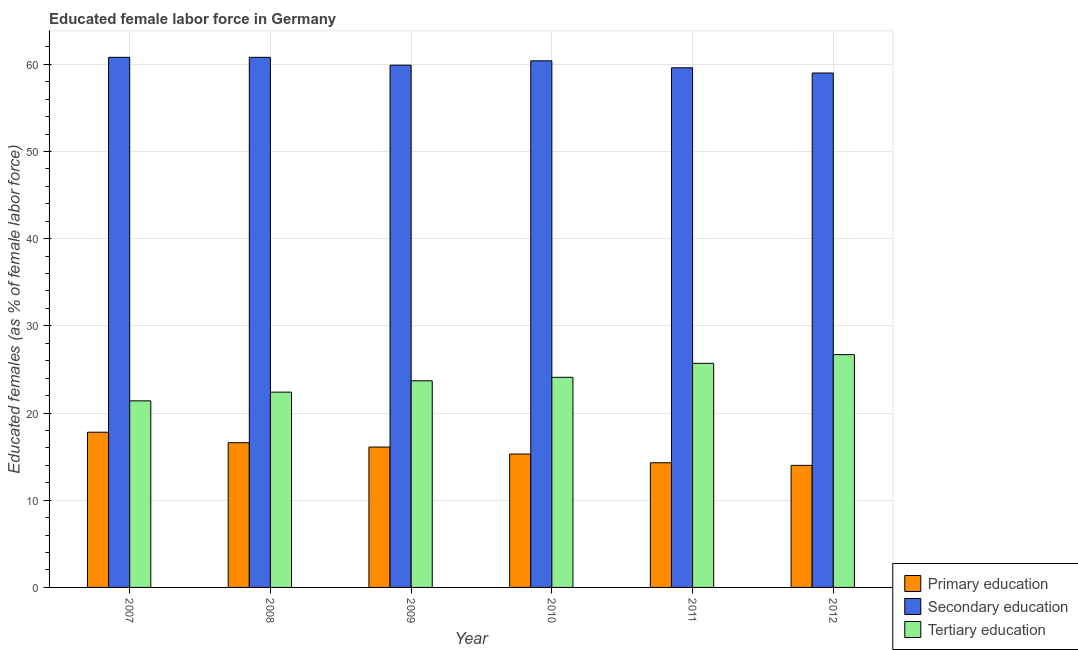How many different coloured bars are there?
Provide a short and direct response. 3. How many groups of bars are there?
Your answer should be very brief. 6. Are the number of bars per tick equal to the number of legend labels?
Ensure brevity in your answer.  Yes. Are the number of bars on each tick of the X-axis equal?
Provide a succinct answer. Yes. How many bars are there on the 4th tick from the right?
Offer a very short reply. 3. What is the percentage of female labor force who received tertiary education in 2011?
Your answer should be compact. 25.7. Across all years, what is the maximum percentage of female labor force who received secondary education?
Provide a short and direct response. 60.8. Across all years, what is the minimum percentage of female labor force who received primary education?
Keep it short and to the point. 14. In which year was the percentage of female labor force who received primary education minimum?
Offer a terse response. 2012. What is the total percentage of female labor force who received primary education in the graph?
Make the answer very short. 94.1. What is the difference between the percentage of female labor force who received secondary education in 2007 and that in 2008?
Offer a very short reply. 0. What is the average percentage of female labor force who received tertiary education per year?
Your answer should be very brief. 24. In how many years, is the percentage of female labor force who received secondary education greater than 48 %?
Provide a short and direct response. 6. What is the ratio of the percentage of female labor force who received primary education in 2008 to that in 2011?
Ensure brevity in your answer.  1.16. What is the difference between the highest and the lowest percentage of female labor force who received secondary education?
Offer a terse response. 1.8. Is the sum of the percentage of female labor force who received secondary education in 2008 and 2012 greater than the maximum percentage of female labor force who received primary education across all years?
Offer a terse response. Yes. What does the 1st bar from the left in 2009 represents?
Provide a short and direct response. Primary education. Are all the bars in the graph horizontal?
Provide a short and direct response. No. What is the difference between two consecutive major ticks on the Y-axis?
Make the answer very short. 10. Are the values on the major ticks of Y-axis written in scientific E-notation?
Offer a very short reply. No. Does the graph contain any zero values?
Ensure brevity in your answer.  No. Does the graph contain grids?
Your response must be concise. Yes. Where does the legend appear in the graph?
Make the answer very short. Bottom right. How many legend labels are there?
Offer a terse response. 3. What is the title of the graph?
Make the answer very short. Educated female labor force in Germany. Does "Errors" appear as one of the legend labels in the graph?
Offer a terse response. No. What is the label or title of the X-axis?
Provide a short and direct response. Year. What is the label or title of the Y-axis?
Ensure brevity in your answer.  Educated females (as % of female labor force). What is the Educated females (as % of female labor force) of Primary education in 2007?
Give a very brief answer. 17.8. What is the Educated females (as % of female labor force) of Secondary education in 2007?
Offer a very short reply. 60.8. What is the Educated females (as % of female labor force) of Tertiary education in 2007?
Your response must be concise. 21.4. What is the Educated females (as % of female labor force) in Primary education in 2008?
Ensure brevity in your answer.  16.6. What is the Educated females (as % of female labor force) in Secondary education in 2008?
Ensure brevity in your answer.  60.8. What is the Educated females (as % of female labor force) in Tertiary education in 2008?
Keep it short and to the point. 22.4. What is the Educated females (as % of female labor force) in Primary education in 2009?
Give a very brief answer. 16.1. What is the Educated females (as % of female labor force) of Secondary education in 2009?
Offer a very short reply. 59.9. What is the Educated females (as % of female labor force) of Tertiary education in 2009?
Offer a very short reply. 23.7. What is the Educated females (as % of female labor force) of Primary education in 2010?
Make the answer very short. 15.3. What is the Educated females (as % of female labor force) in Secondary education in 2010?
Provide a succinct answer. 60.4. What is the Educated females (as % of female labor force) in Tertiary education in 2010?
Keep it short and to the point. 24.1. What is the Educated females (as % of female labor force) of Primary education in 2011?
Offer a very short reply. 14.3. What is the Educated females (as % of female labor force) in Secondary education in 2011?
Offer a very short reply. 59.6. What is the Educated females (as % of female labor force) of Tertiary education in 2011?
Your response must be concise. 25.7. What is the Educated females (as % of female labor force) of Tertiary education in 2012?
Give a very brief answer. 26.7. Across all years, what is the maximum Educated females (as % of female labor force) in Primary education?
Ensure brevity in your answer.  17.8. Across all years, what is the maximum Educated females (as % of female labor force) of Secondary education?
Offer a terse response. 60.8. Across all years, what is the maximum Educated females (as % of female labor force) in Tertiary education?
Ensure brevity in your answer.  26.7. Across all years, what is the minimum Educated females (as % of female labor force) in Primary education?
Offer a very short reply. 14. Across all years, what is the minimum Educated females (as % of female labor force) of Secondary education?
Make the answer very short. 59. Across all years, what is the minimum Educated females (as % of female labor force) in Tertiary education?
Provide a short and direct response. 21.4. What is the total Educated females (as % of female labor force) in Primary education in the graph?
Your response must be concise. 94.1. What is the total Educated females (as % of female labor force) in Secondary education in the graph?
Your response must be concise. 360.5. What is the total Educated females (as % of female labor force) of Tertiary education in the graph?
Offer a terse response. 144. What is the difference between the Educated females (as % of female labor force) in Tertiary education in 2007 and that in 2008?
Ensure brevity in your answer.  -1. What is the difference between the Educated females (as % of female labor force) of Secondary education in 2007 and that in 2009?
Your response must be concise. 0.9. What is the difference between the Educated females (as % of female labor force) in Primary education in 2007 and that in 2010?
Offer a terse response. 2.5. What is the difference between the Educated females (as % of female labor force) in Primary education in 2007 and that in 2012?
Offer a very short reply. 3.8. What is the difference between the Educated females (as % of female labor force) in Secondary education in 2007 and that in 2012?
Ensure brevity in your answer.  1.8. What is the difference between the Educated females (as % of female labor force) of Primary education in 2008 and that in 2010?
Offer a very short reply. 1.3. What is the difference between the Educated females (as % of female labor force) in Secondary education in 2008 and that in 2011?
Your answer should be very brief. 1.2. What is the difference between the Educated females (as % of female labor force) in Primary education in 2008 and that in 2012?
Make the answer very short. 2.6. What is the difference between the Educated females (as % of female labor force) of Secondary education in 2008 and that in 2012?
Offer a very short reply. 1.8. What is the difference between the Educated females (as % of female labor force) in Primary education in 2009 and that in 2010?
Provide a short and direct response. 0.8. What is the difference between the Educated females (as % of female labor force) in Secondary education in 2009 and that in 2010?
Your response must be concise. -0.5. What is the difference between the Educated females (as % of female labor force) of Primary education in 2009 and that in 2011?
Ensure brevity in your answer.  1.8. What is the difference between the Educated females (as % of female labor force) of Tertiary education in 2009 and that in 2011?
Provide a short and direct response. -2. What is the difference between the Educated females (as % of female labor force) of Secondary education in 2009 and that in 2012?
Provide a short and direct response. 0.9. What is the difference between the Educated females (as % of female labor force) of Tertiary education in 2009 and that in 2012?
Offer a terse response. -3. What is the difference between the Educated females (as % of female labor force) in Secondary education in 2010 and that in 2011?
Make the answer very short. 0.8. What is the difference between the Educated females (as % of female labor force) in Secondary education in 2010 and that in 2012?
Offer a very short reply. 1.4. What is the difference between the Educated females (as % of female labor force) of Primary education in 2011 and that in 2012?
Your answer should be very brief. 0.3. What is the difference between the Educated females (as % of female labor force) in Secondary education in 2011 and that in 2012?
Ensure brevity in your answer.  0.6. What is the difference between the Educated females (as % of female labor force) in Tertiary education in 2011 and that in 2012?
Give a very brief answer. -1. What is the difference between the Educated females (as % of female labor force) in Primary education in 2007 and the Educated females (as % of female labor force) in Secondary education in 2008?
Provide a short and direct response. -43. What is the difference between the Educated females (as % of female labor force) of Primary education in 2007 and the Educated females (as % of female labor force) of Tertiary education in 2008?
Keep it short and to the point. -4.6. What is the difference between the Educated females (as % of female labor force) of Secondary education in 2007 and the Educated females (as % of female labor force) of Tertiary education in 2008?
Your answer should be very brief. 38.4. What is the difference between the Educated females (as % of female labor force) in Primary education in 2007 and the Educated females (as % of female labor force) in Secondary education in 2009?
Ensure brevity in your answer.  -42.1. What is the difference between the Educated females (as % of female labor force) in Primary education in 2007 and the Educated females (as % of female labor force) in Tertiary education in 2009?
Make the answer very short. -5.9. What is the difference between the Educated females (as % of female labor force) of Secondary education in 2007 and the Educated females (as % of female labor force) of Tertiary education in 2009?
Give a very brief answer. 37.1. What is the difference between the Educated females (as % of female labor force) in Primary education in 2007 and the Educated females (as % of female labor force) in Secondary education in 2010?
Offer a very short reply. -42.6. What is the difference between the Educated females (as % of female labor force) of Secondary education in 2007 and the Educated females (as % of female labor force) of Tertiary education in 2010?
Ensure brevity in your answer.  36.7. What is the difference between the Educated females (as % of female labor force) of Primary education in 2007 and the Educated females (as % of female labor force) of Secondary education in 2011?
Make the answer very short. -41.8. What is the difference between the Educated females (as % of female labor force) in Primary education in 2007 and the Educated females (as % of female labor force) in Tertiary education in 2011?
Offer a very short reply. -7.9. What is the difference between the Educated females (as % of female labor force) of Secondary education in 2007 and the Educated females (as % of female labor force) of Tertiary education in 2011?
Ensure brevity in your answer.  35.1. What is the difference between the Educated females (as % of female labor force) in Primary education in 2007 and the Educated females (as % of female labor force) in Secondary education in 2012?
Ensure brevity in your answer.  -41.2. What is the difference between the Educated females (as % of female labor force) in Secondary education in 2007 and the Educated females (as % of female labor force) in Tertiary education in 2012?
Provide a succinct answer. 34.1. What is the difference between the Educated females (as % of female labor force) in Primary education in 2008 and the Educated females (as % of female labor force) in Secondary education in 2009?
Offer a very short reply. -43.3. What is the difference between the Educated females (as % of female labor force) in Secondary education in 2008 and the Educated females (as % of female labor force) in Tertiary education in 2009?
Your response must be concise. 37.1. What is the difference between the Educated females (as % of female labor force) of Primary education in 2008 and the Educated females (as % of female labor force) of Secondary education in 2010?
Your answer should be very brief. -43.8. What is the difference between the Educated females (as % of female labor force) in Secondary education in 2008 and the Educated females (as % of female labor force) in Tertiary education in 2010?
Offer a very short reply. 36.7. What is the difference between the Educated females (as % of female labor force) in Primary education in 2008 and the Educated females (as % of female labor force) in Secondary education in 2011?
Your answer should be compact. -43. What is the difference between the Educated females (as % of female labor force) of Primary education in 2008 and the Educated females (as % of female labor force) of Tertiary education in 2011?
Offer a terse response. -9.1. What is the difference between the Educated females (as % of female labor force) of Secondary education in 2008 and the Educated females (as % of female labor force) of Tertiary education in 2011?
Provide a short and direct response. 35.1. What is the difference between the Educated females (as % of female labor force) in Primary education in 2008 and the Educated females (as % of female labor force) in Secondary education in 2012?
Give a very brief answer. -42.4. What is the difference between the Educated females (as % of female labor force) of Primary education in 2008 and the Educated females (as % of female labor force) of Tertiary education in 2012?
Provide a short and direct response. -10.1. What is the difference between the Educated females (as % of female labor force) in Secondary education in 2008 and the Educated females (as % of female labor force) in Tertiary education in 2012?
Your answer should be very brief. 34.1. What is the difference between the Educated females (as % of female labor force) in Primary education in 2009 and the Educated females (as % of female labor force) in Secondary education in 2010?
Make the answer very short. -44.3. What is the difference between the Educated females (as % of female labor force) in Primary education in 2009 and the Educated females (as % of female labor force) in Tertiary education in 2010?
Offer a terse response. -8. What is the difference between the Educated females (as % of female labor force) of Secondary education in 2009 and the Educated females (as % of female labor force) of Tertiary education in 2010?
Provide a short and direct response. 35.8. What is the difference between the Educated females (as % of female labor force) in Primary education in 2009 and the Educated females (as % of female labor force) in Secondary education in 2011?
Your answer should be very brief. -43.5. What is the difference between the Educated females (as % of female labor force) of Primary education in 2009 and the Educated females (as % of female labor force) of Tertiary education in 2011?
Offer a terse response. -9.6. What is the difference between the Educated females (as % of female labor force) of Secondary education in 2009 and the Educated females (as % of female labor force) of Tertiary education in 2011?
Provide a succinct answer. 34.2. What is the difference between the Educated females (as % of female labor force) in Primary education in 2009 and the Educated females (as % of female labor force) in Secondary education in 2012?
Your answer should be very brief. -42.9. What is the difference between the Educated females (as % of female labor force) in Secondary education in 2009 and the Educated females (as % of female labor force) in Tertiary education in 2012?
Give a very brief answer. 33.2. What is the difference between the Educated females (as % of female labor force) in Primary education in 2010 and the Educated females (as % of female labor force) in Secondary education in 2011?
Provide a short and direct response. -44.3. What is the difference between the Educated females (as % of female labor force) of Primary education in 2010 and the Educated females (as % of female labor force) of Tertiary education in 2011?
Keep it short and to the point. -10.4. What is the difference between the Educated females (as % of female labor force) in Secondary education in 2010 and the Educated females (as % of female labor force) in Tertiary education in 2011?
Your answer should be very brief. 34.7. What is the difference between the Educated females (as % of female labor force) in Primary education in 2010 and the Educated females (as % of female labor force) in Secondary education in 2012?
Provide a succinct answer. -43.7. What is the difference between the Educated females (as % of female labor force) of Secondary education in 2010 and the Educated females (as % of female labor force) of Tertiary education in 2012?
Keep it short and to the point. 33.7. What is the difference between the Educated females (as % of female labor force) of Primary education in 2011 and the Educated females (as % of female labor force) of Secondary education in 2012?
Make the answer very short. -44.7. What is the difference between the Educated females (as % of female labor force) in Primary education in 2011 and the Educated females (as % of female labor force) in Tertiary education in 2012?
Give a very brief answer. -12.4. What is the difference between the Educated females (as % of female labor force) in Secondary education in 2011 and the Educated females (as % of female labor force) in Tertiary education in 2012?
Your response must be concise. 32.9. What is the average Educated females (as % of female labor force) in Primary education per year?
Your answer should be very brief. 15.68. What is the average Educated females (as % of female labor force) in Secondary education per year?
Your answer should be compact. 60.08. In the year 2007, what is the difference between the Educated females (as % of female labor force) in Primary education and Educated females (as % of female labor force) in Secondary education?
Make the answer very short. -43. In the year 2007, what is the difference between the Educated females (as % of female labor force) of Primary education and Educated females (as % of female labor force) of Tertiary education?
Ensure brevity in your answer.  -3.6. In the year 2007, what is the difference between the Educated females (as % of female labor force) of Secondary education and Educated females (as % of female labor force) of Tertiary education?
Your answer should be compact. 39.4. In the year 2008, what is the difference between the Educated females (as % of female labor force) of Primary education and Educated females (as % of female labor force) of Secondary education?
Give a very brief answer. -44.2. In the year 2008, what is the difference between the Educated females (as % of female labor force) of Secondary education and Educated females (as % of female labor force) of Tertiary education?
Your answer should be very brief. 38.4. In the year 2009, what is the difference between the Educated females (as % of female labor force) in Primary education and Educated females (as % of female labor force) in Secondary education?
Give a very brief answer. -43.8. In the year 2009, what is the difference between the Educated females (as % of female labor force) in Secondary education and Educated females (as % of female labor force) in Tertiary education?
Keep it short and to the point. 36.2. In the year 2010, what is the difference between the Educated females (as % of female labor force) in Primary education and Educated females (as % of female labor force) in Secondary education?
Ensure brevity in your answer.  -45.1. In the year 2010, what is the difference between the Educated females (as % of female labor force) of Primary education and Educated females (as % of female labor force) of Tertiary education?
Your response must be concise. -8.8. In the year 2010, what is the difference between the Educated females (as % of female labor force) of Secondary education and Educated females (as % of female labor force) of Tertiary education?
Ensure brevity in your answer.  36.3. In the year 2011, what is the difference between the Educated females (as % of female labor force) in Primary education and Educated females (as % of female labor force) in Secondary education?
Provide a short and direct response. -45.3. In the year 2011, what is the difference between the Educated females (as % of female labor force) in Primary education and Educated females (as % of female labor force) in Tertiary education?
Provide a short and direct response. -11.4. In the year 2011, what is the difference between the Educated females (as % of female labor force) of Secondary education and Educated females (as % of female labor force) of Tertiary education?
Keep it short and to the point. 33.9. In the year 2012, what is the difference between the Educated females (as % of female labor force) of Primary education and Educated females (as % of female labor force) of Secondary education?
Your answer should be very brief. -45. In the year 2012, what is the difference between the Educated females (as % of female labor force) of Primary education and Educated females (as % of female labor force) of Tertiary education?
Your answer should be compact. -12.7. In the year 2012, what is the difference between the Educated females (as % of female labor force) of Secondary education and Educated females (as % of female labor force) of Tertiary education?
Offer a very short reply. 32.3. What is the ratio of the Educated females (as % of female labor force) of Primary education in 2007 to that in 2008?
Your answer should be very brief. 1.07. What is the ratio of the Educated females (as % of female labor force) of Tertiary education in 2007 to that in 2008?
Provide a succinct answer. 0.96. What is the ratio of the Educated females (as % of female labor force) of Primary education in 2007 to that in 2009?
Ensure brevity in your answer.  1.11. What is the ratio of the Educated females (as % of female labor force) of Tertiary education in 2007 to that in 2009?
Make the answer very short. 0.9. What is the ratio of the Educated females (as % of female labor force) in Primary education in 2007 to that in 2010?
Offer a very short reply. 1.16. What is the ratio of the Educated females (as % of female labor force) in Secondary education in 2007 to that in 2010?
Offer a very short reply. 1.01. What is the ratio of the Educated females (as % of female labor force) of Tertiary education in 2007 to that in 2010?
Offer a terse response. 0.89. What is the ratio of the Educated females (as % of female labor force) of Primary education in 2007 to that in 2011?
Make the answer very short. 1.24. What is the ratio of the Educated females (as % of female labor force) of Secondary education in 2007 to that in 2011?
Keep it short and to the point. 1.02. What is the ratio of the Educated females (as % of female labor force) in Tertiary education in 2007 to that in 2011?
Give a very brief answer. 0.83. What is the ratio of the Educated females (as % of female labor force) in Primary education in 2007 to that in 2012?
Keep it short and to the point. 1.27. What is the ratio of the Educated females (as % of female labor force) in Secondary education in 2007 to that in 2012?
Keep it short and to the point. 1.03. What is the ratio of the Educated females (as % of female labor force) in Tertiary education in 2007 to that in 2012?
Provide a succinct answer. 0.8. What is the ratio of the Educated females (as % of female labor force) in Primary education in 2008 to that in 2009?
Provide a short and direct response. 1.03. What is the ratio of the Educated females (as % of female labor force) in Tertiary education in 2008 to that in 2009?
Offer a terse response. 0.95. What is the ratio of the Educated females (as % of female labor force) in Primary education in 2008 to that in 2010?
Offer a very short reply. 1.08. What is the ratio of the Educated females (as % of female labor force) of Secondary education in 2008 to that in 2010?
Your answer should be compact. 1.01. What is the ratio of the Educated females (as % of female labor force) of Tertiary education in 2008 to that in 2010?
Your response must be concise. 0.93. What is the ratio of the Educated females (as % of female labor force) of Primary education in 2008 to that in 2011?
Give a very brief answer. 1.16. What is the ratio of the Educated females (as % of female labor force) in Secondary education in 2008 to that in 2011?
Your response must be concise. 1.02. What is the ratio of the Educated females (as % of female labor force) in Tertiary education in 2008 to that in 2011?
Keep it short and to the point. 0.87. What is the ratio of the Educated females (as % of female labor force) in Primary education in 2008 to that in 2012?
Your answer should be compact. 1.19. What is the ratio of the Educated females (as % of female labor force) in Secondary education in 2008 to that in 2012?
Ensure brevity in your answer.  1.03. What is the ratio of the Educated females (as % of female labor force) of Tertiary education in 2008 to that in 2012?
Your answer should be compact. 0.84. What is the ratio of the Educated females (as % of female labor force) of Primary education in 2009 to that in 2010?
Offer a terse response. 1.05. What is the ratio of the Educated females (as % of female labor force) of Tertiary education in 2009 to that in 2010?
Ensure brevity in your answer.  0.98. What is the ratio of the Educated females (as % of female labor force) in Primary education in 2009 to that in 2011?
Offer a terse response. 1.13. What is the ratio of the Educated females (as % of female labor force) of Tertiary education in 2009 to that in 2011?
Ensure brevity in your answer.  0.92. What is the ratio of the Educated females (as % of female labor force) of Primary education in 2009 to that in 2012?
Give a very brief answer. 1.15. What is the ratio of the Educated females (as % of female labor force) of Secondary education in 2009 to that in 2012?
Your answer should be very brief. 1.02. What is the ratio of the Educated females (as % of female labor force) in Tertiary education in 2009 to that in 2012?
Make the answer very short. 0.89. What is the ratio of the Educated females (as % of female labor force) of Primary education in 2010 to that in 2011?
Offer a terse response. 1.07. What is the ratio of the Educated females (as % of female labor force) in Secondary education in 2010 to that in 2011?
Your answer should be very brief. 1.01. What is the ratio of the Educated females (as % of female labor force) in Tertiary education in 2010 to that in 2011?
Provide a short and direct response. 0.94. What is the ratio of the Educated females (as % of female labor force) of Primary education in 2010 to that in 2012?
Keep it short and to the point. 1.09. What is the ratio of the Educated females (as % of female labor force) of Secondary education in 2010 to that in 2012?
Offer a very short reply. 1.02. What is the ratio of the Educated females (as % of female labor force) of Tertiary education in 2010 to that in 2012?
Offer a terse response. 0.9. What is the ratio of the Educated females (as % of female labor force) in Primary education in 2011 to that in 2012?
Keep it short and to the point. 1.02. What is the ratio of the Educated females (as % of female labor force) in Secondary education in 2011 to that in 2012?
Give a very brief answer. 1.01. What is the ratio of the Educated females (as % of female labor force) of Tertiary education in 2011 to that in 2012?
Offer a terse response. 0.96. What is the difference between the highest and the second highest Educated females (as % of female labor force) of Primary education?
Provide a short and direct response. 1.2. What is the difference between the highest and the second highest Educated females (as % of female labor force) of Secondary education?
Ensure brevity in your answer.  0. What is the difference between the highest and the lowest Educated females (as % of female labor force) of Primary education?
Your answer should be compact. 3.8. What is the difference between the highest and the lowest Educated females (as % of female labor force) of Secondary education?
Your answer should be compact. 1.8. 